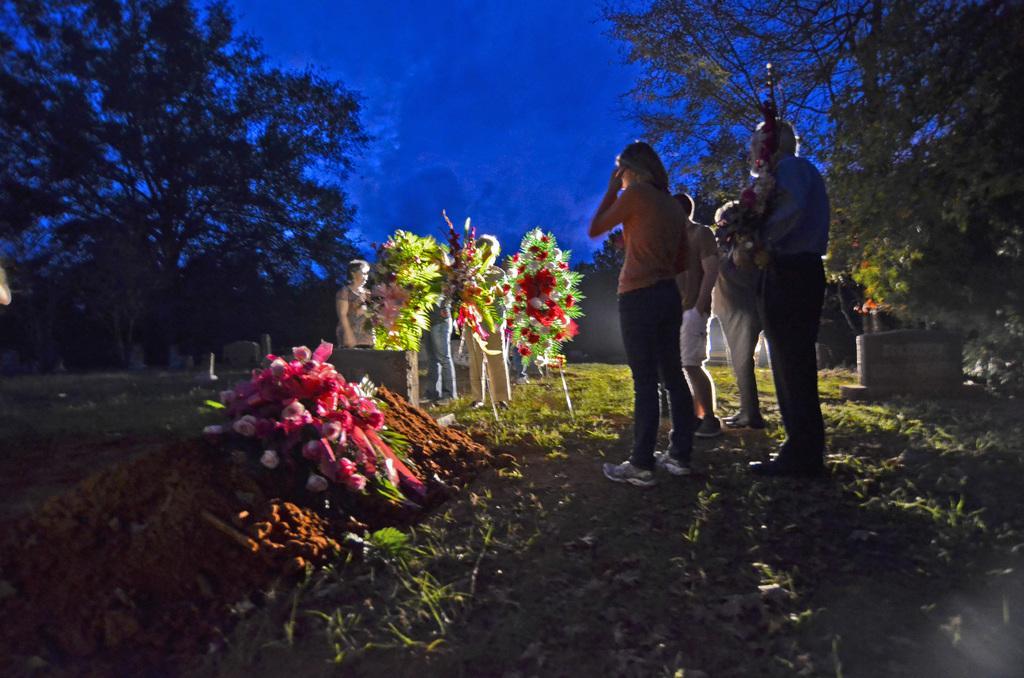Please provide a concise description of this image. There are groups of people standing. I can see a flower bouquet placed on the mud. I can see few people holding flower bouquets. This is the graveyard. These are the trees. Here is the grass. 